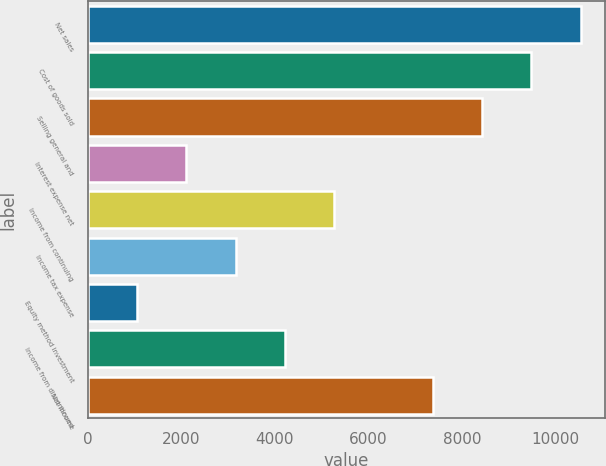<chart> <loc_0><loc_0><loc_500><loc_500><bar_chart><fcel>Net sales<fcel>Cost of goods sold<fcel>Selling general and<fcel>Interest expense net<fcel>Income from continuing<fcel>Income tax expense<fcel>Equity method investment<fcel>Income from discontinued<fcel>Net income<nl><fcel>10531.7<fcel>9478.55<fcel>8425.44<fcel>2106.78<fcel>5266.11<fcel>3159.89<fcel>1053.67<fcel>4213<fcel>7372.33<nl></chart> 